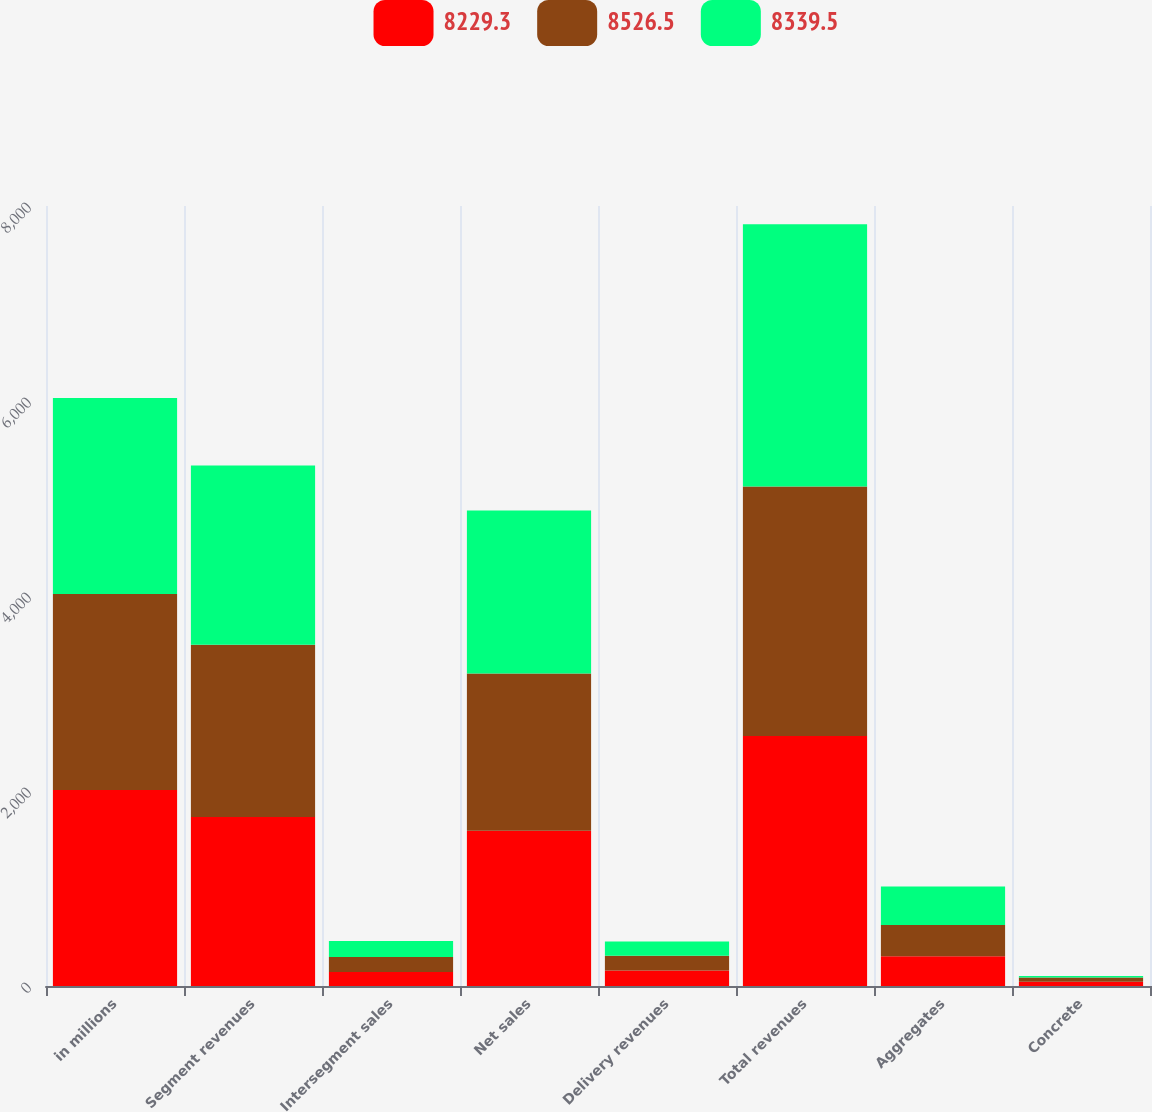Convert chart. <chart><loc_0><loc_0><loc_500><loc_500><stacked_bar_chart><ecel><fcel>in millions<fcel>Segment revenues<fcel>Intersegment sales<fcel>Net sales<fcel>Delivery revenues<fcel>Total revenues<fcel>Aggregates<fcel>Concrete<nl><fcel>8229.3<fcel>2011<fcel>1734<fcel>142.6<fcel>1591.4<fcel>157.7<fcel>2564.6<fcel>306.2<fcel>43.4<nl><fcel>8526.5<fcel>2010<fcel>1766.9<fcel>154.1<fcel>1612.8<fcel>153<fcel>2558.9<fcel>320.2<fcel>45<nl><fcel>8339.5<fcel>2009<fcel>1838.6<fcel>165.2<fcel>1673.4<fcel>146.8<fcel>2690.5<fcel>393.3<fcel>14.5<nl></chart> 